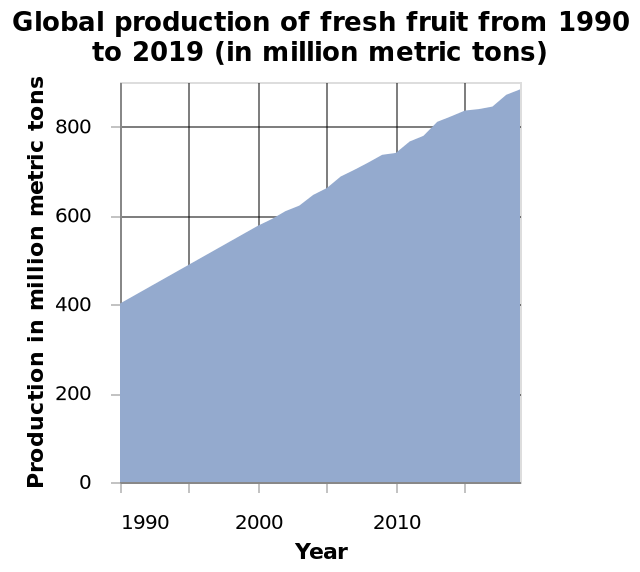<image>
please enumerates aspects of the construction of the chart Global production of fresh fruit from 1990 to 2019 (in million metric tons) is a area plot. Year is measured on the x-axis. On the y-axis, Production in million metric tons is plotted. Did global fruit production decrease or increase from 2015 to 2019? Global production of fruit from 2015 to 2019 doubled. 